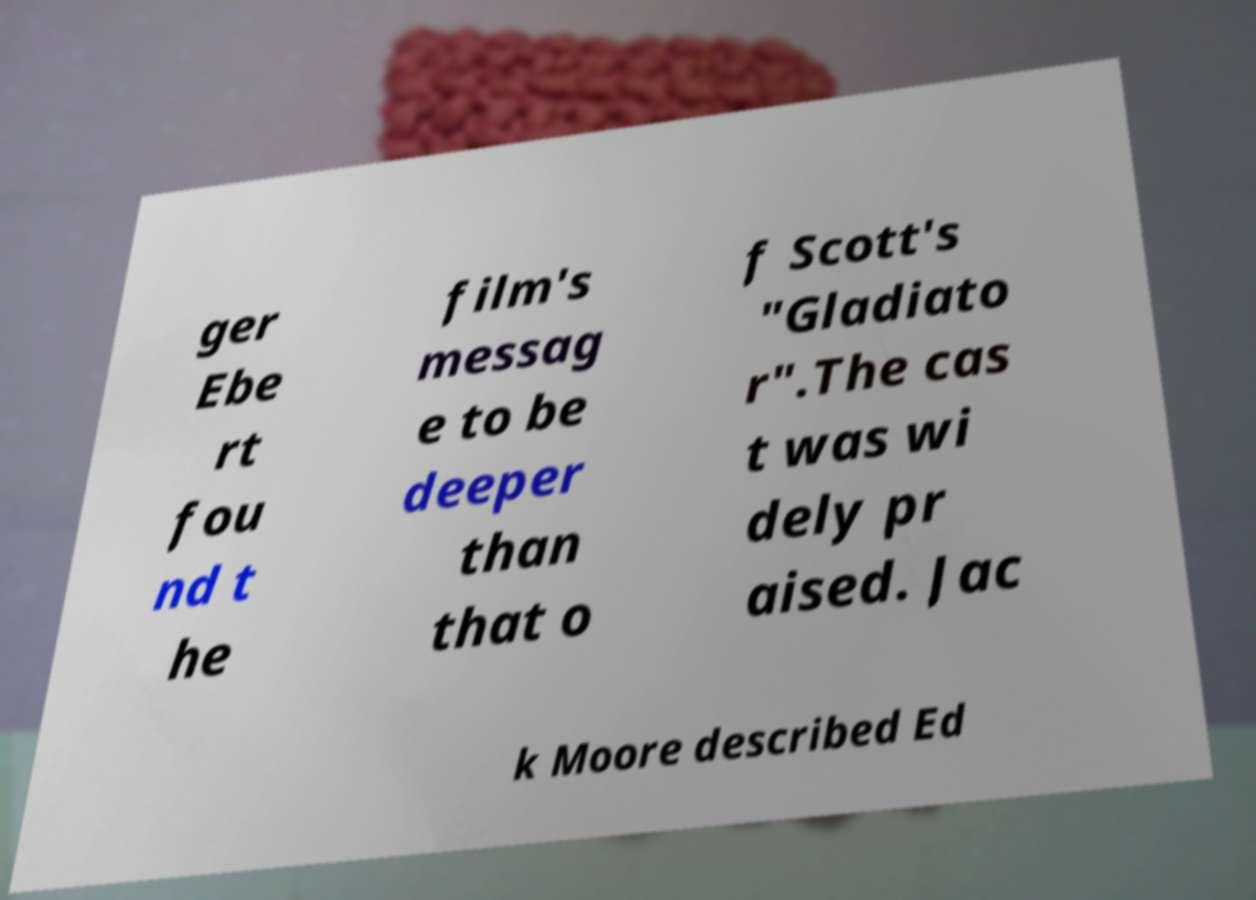There's text embedded in this image that I need extracted. Can you transcribe it verbatim? ger Ebe rt fou nd t he film's messag e to be deeper than that o f Scott's "Gladiato r".The cas t was wi dely pr aised. Jac k Moore described Ed 